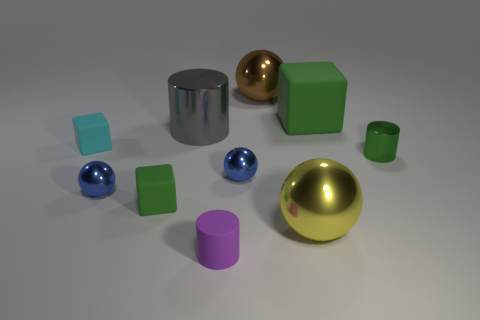There is a green thing that is both to the left of the tiny green metal object and right of the gray object; what is its shape?
Give a very brief answer. Cube. Are there any small gray objects that have the same material as the gray cylinder?
Give a very brief answer. No. There is a tiny cylinder that is the same color as the big cube; what material is it?
Offer a terse response. Metal. Does the large sphere in front of the tiny cyan matte block have the same material as the tiny green thing in front of the tiny green metallic thing?
Ensure brevity in your answer.  No. Are there more matte objects than large red spheres?
Your response must be concise. Yes. What color is the metallic thing in front of the green block left of the big metal ball in front of the green metallic thing?
Your answer should be compact. Yellow. There is a small metal object that is left of the tiny purple rubber thing; is its color the same as the big shiny ball behind the big yellow metal ball?
Your answer should be very brief. No. What number of tiny green matte objects are behind the cube to the right of the gray metallic thing?
Make the answer very short. 0. Is there a purple matte object?
Ensure brevity in your answer.  Yes. How many other objects are the same color as the matte cylinder?
Make the answer very short. 0. 